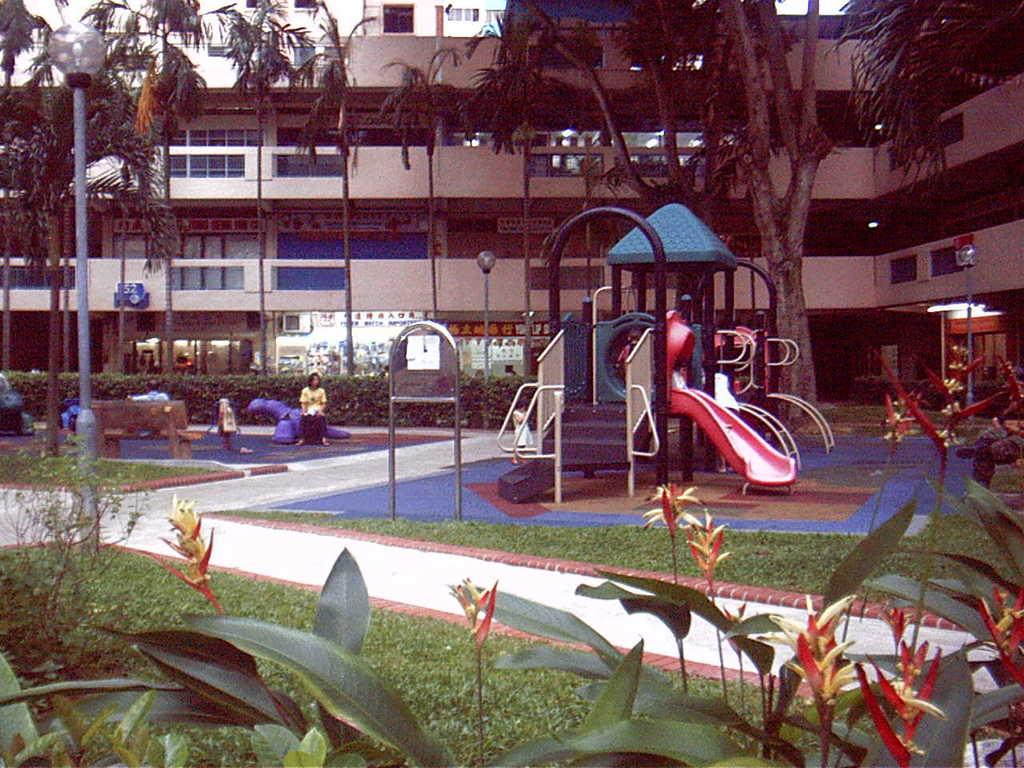What type of area is depicted in the image? There is a play area for children in the image. What natural elements can be seen in the image? Trees are present in the image. What can be seen in the background of the image? There is a building in the background of the image. Where is the girl using the hammer in the image? There is no girl using a hammer in the image. 